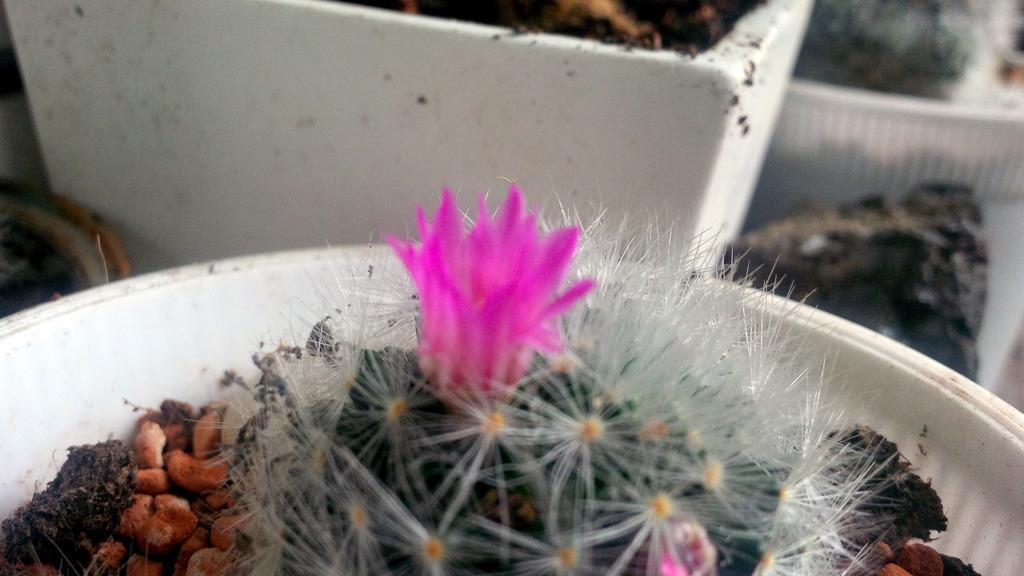What type of plant is in the image? There is a plant in the image, but the specific type cannot be determined from the provided facts. What can be seen growing on the plant? There are flowers in the image. What type of material is present in the image? There are stones in the image. What is the plant placed in? There is a plant pot in the image. What can be seen in the background of the image? There is soil visible in the background of the image. How would you describe the background of the image? The background of the image appears blurry. Where is the market located in the image? There is no market present in the image. What type of jewel is the plant wearing in the image? There is no jewel present in the image. 